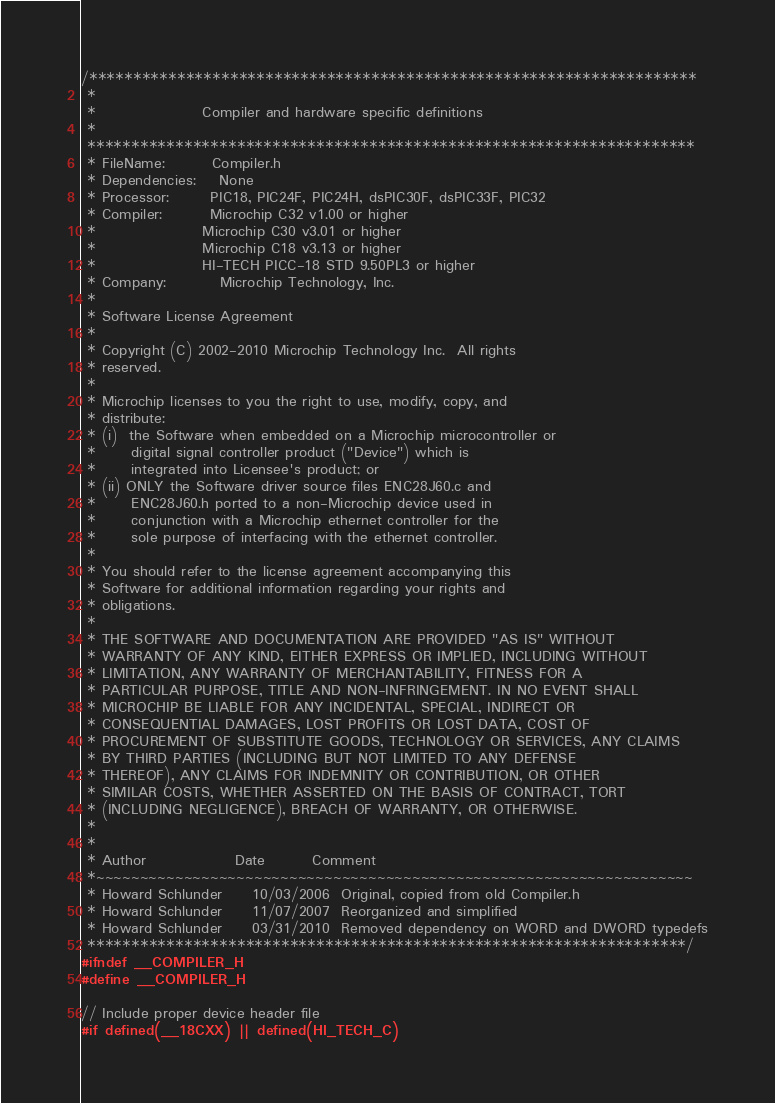<code> <loc_0><loc_0><loc_500><loc_500><_C_>/*********************************************************************
 *
 *                  Compiler and hardware specific definitions
 *
 *********************************************************************
 * FileName:        Compiler.h
 * Dependencies:    None
 * Processor:       PIC18, PIC24F, PIC24H, dsPIC30F, dsPIC33F, PIC32
 * Compiler:        Microchip C32 v1.00 or higher
 *					Microchip C30 v3.01 or higher
 *					Microchip C18 v3.13 or higher
 *					HI-TECH PICC-18 STD 9.50PL3 or higher
 * Company:         Microchip Technology, Inc.
 *
 * Software License Agreement
 *
 * Copyright (C) 2002-2010 Microchip Technology Inc.  All rights 
 * reserved.
 *
 * Microchip licenses to you the right to use, modify, copy, and 
 * distribute: 
 * (i)  the Software when embedded on a Microchip microcontroller or 
 *      digital signal controller product ("Device") which is 
 *      integrated into Licensee's product; or
 * (ii) ONLY the Software driver source files ENC28J60.c and 
 *      ENC28J60.h ported to a non-Microchip device used in 
 *      conjunction with a Microchip ethernet controller for the 
 *      sole purpose of interfacing with the ethernet controller. 
 *
 * You should refer to the license agreement accompanying this 
 * Software for additional information regarding your rights and 
 * obligations.
 *
 * THE SOFTWARE AND DOCUMENTATION ARE PROVIDED "AS IS" WITHOUT 
 * WARRANTY OF ANY KIND, EITHER EXPRESS OR IMPLIED, INCLUDING WITHOUT 
 * LIMITATION, ANY WARRANTY OF MERCHANTABILITY, FITNESS FOR A 
 * PARTICULAR PURPOSE, TITLE AND NON-INFRINGEMENT. IN NO EVENT SHALL 
 * MICROCHIP BE LIABLE FOR ANY INCIDENTAL, SPECIAL, INDIRECT OR 
 * CONSEQUENTIAL DAMAGES, LOST PROFITS OR LOST DATA, COST OF 
 * PROCUREMENT OF SUBSTITUTE GOODS, TECHNOLOGY OR SERVICES, ANY CLAIMS 
 * BY THIRD PARTIES (INCLUDING BUT NOT LIMITED TO ANY DEFENSE 
 * THEREOF), ANY CLAIMS FOR INDEMNITY OR CONTRIBUTION, OR OTHER 
 * SIMILAR COSTS, WHETHER ASSERTED ON THE BASIS OF CONTRACT, TORT 
 * (INCLUDING NEGLIGENCE), BREACH OF WARRANTY, OR OTHERWISE.
 *
 *
 * Author               Date    	Comment
 *~~~~~~~~~~~~~~~~~~~~~~~~~~~~~~~~~~~~~~~~~~~~~~~~~~~~~~~~~~~~~~~~~~~~
 * Howard Schlunder		10/03/2006	Original, copied from old Compiler.h
 * Howard Schlunder		11/07/2007	Reorganized and simplified
 * Howard Schlunder		03/31/2010	Removed dependency on WORD and DWORD typedefs
 ********************************************************************/
#ifndef __COMPILER_H
#define __COMPILER_H

// Include proper device header file
#if defined(__18CXX) || defined(HI_TECH_C)	</code> 